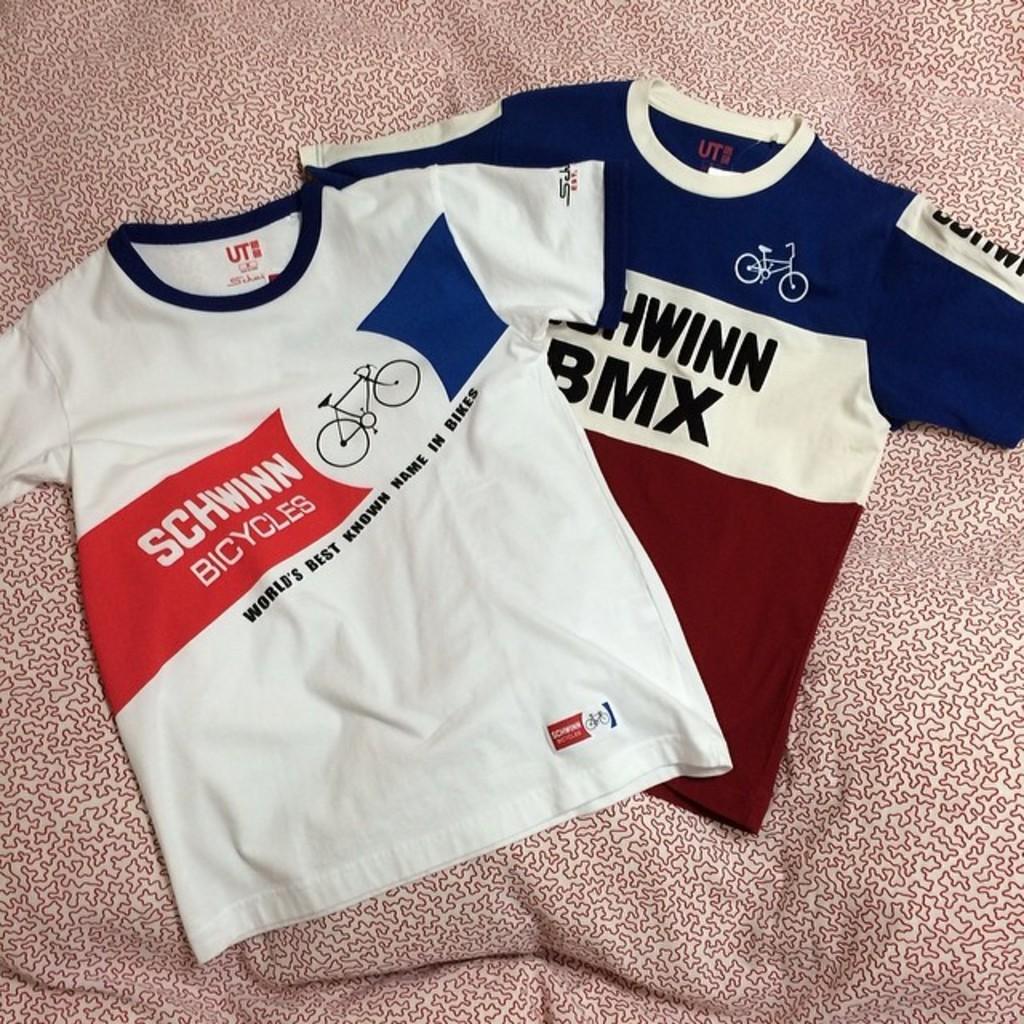What kind of sport is featured on the shirt?
Ensure brevity in your answer.  Bmx. 